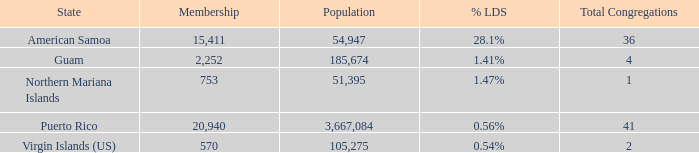Would you mind parsing the complete table? {'header': ['State', 'Membership', 'Population', '% LDS', 'Total Congregations'], 'rows': [['American Samoa', '15,411', '54,947', '28.1%', '36'], ['Guam', '2,252', '185,674', '1.41%', '4'], ['Northern Mariana Islands', '753', '51,395', '1.47%', '1'], ['Puerto Rico', '20,940', '3,667,084', '0.56%', '41'], ['Virgin Islands (US)', '570', '105,275', '0.54%', '2']]} 54% and the total number of congregations exceeds 2? None. 